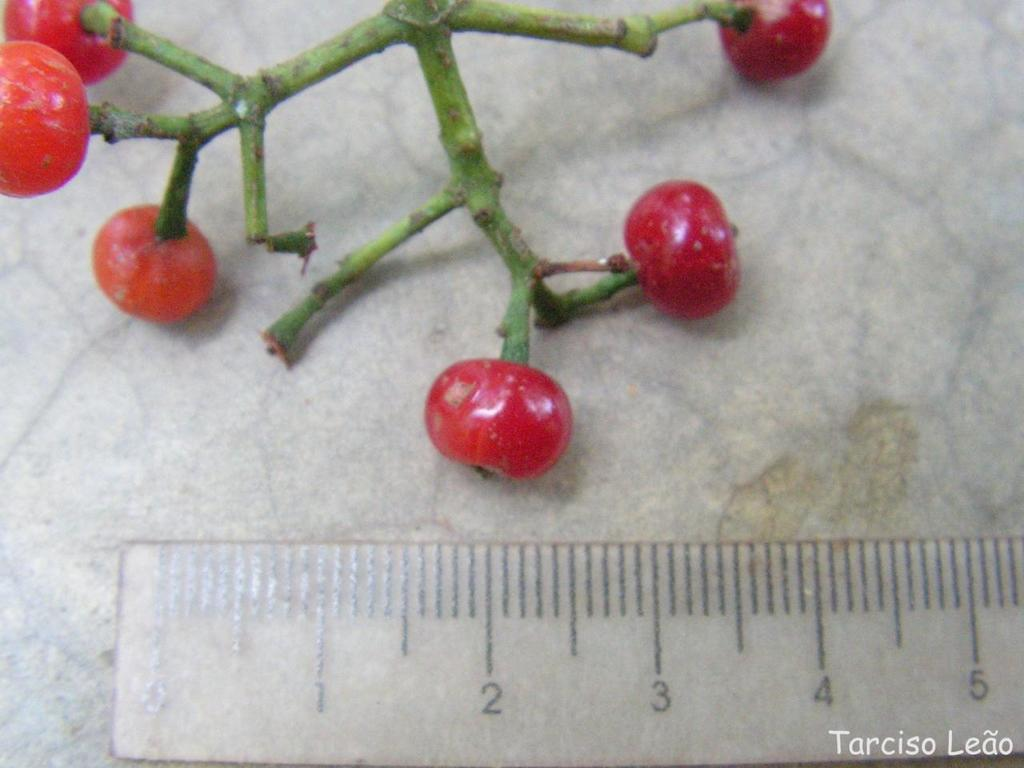Provide a one-sentence caption for the provided image. At the bottom right of this picture of some kind of fruit being measured, it says Tarciso Leao. 